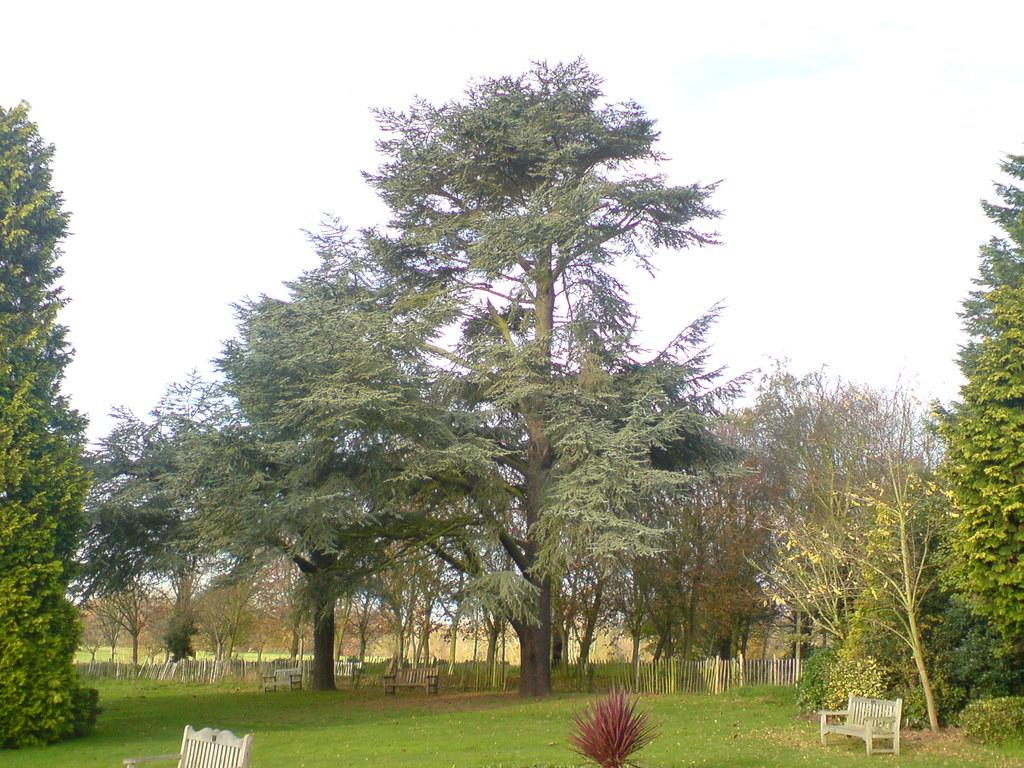What type of vegetation is in the foreground of the image? There is grass in the foreground of the image. What type of seating is available in the foreground of the image? There are benches in the foreground of the image. What type of vegetation is in the middle of the image? There are trees in the middle of the image. What is visible at the top of the image? The sky is visible at the top of the image. How many dogs are visible in the image? There are no dogs present in the image. Can you see an ant crawling on the grass in the image? There is no ant visible in the image. 